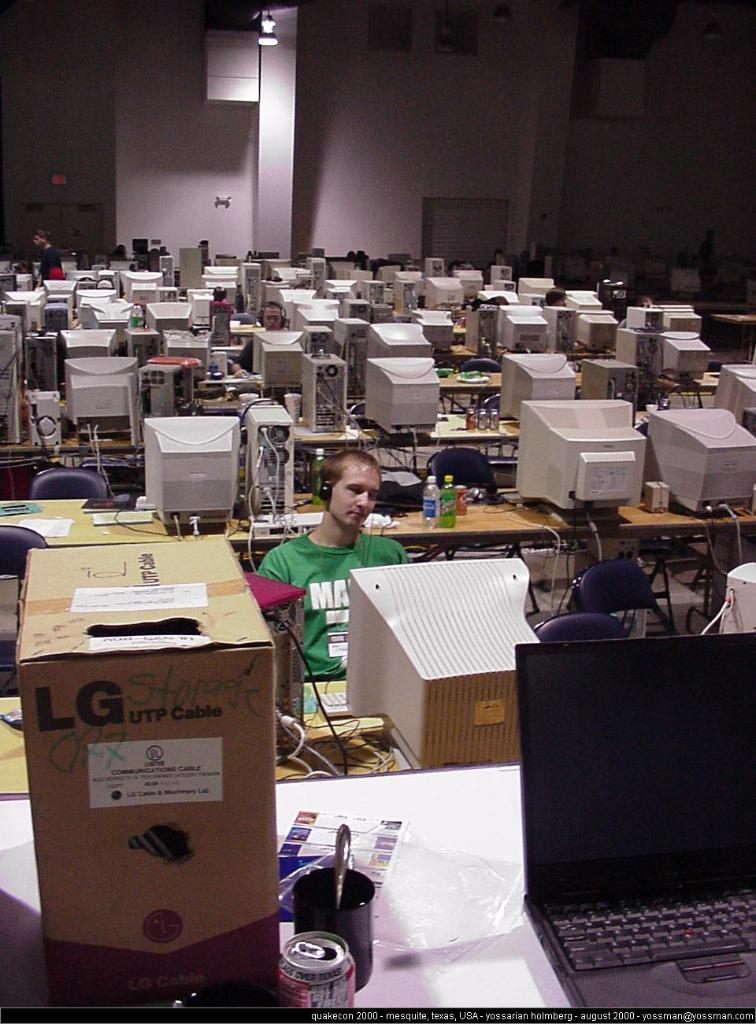<image>
Share a concise interpretation of the image provided. A row of computers with an LG box in the front 